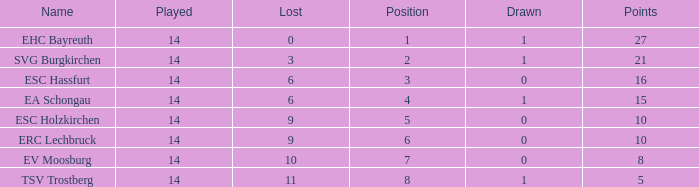What's the lost when there were more than 16 points and had a drawn less than 1? None. 